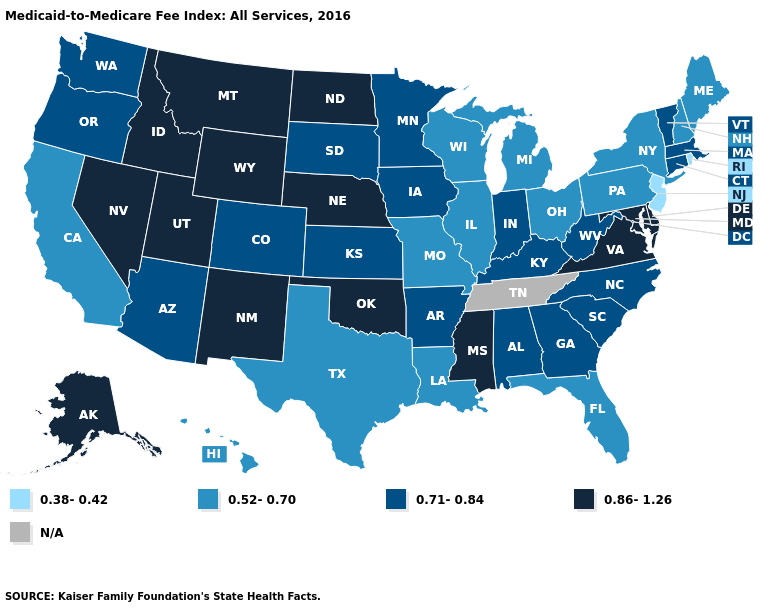What is the value of North Carolina?
Be succinct. 0.71-0.84. What is the highest value in the South ?
Give a very brief answer. 0.86-1.26. What is the lowest value in the USA?
Keep it brief. 0.38-0.42. Name the states that have a value in the range 0.86-1.26?
Be succinct. Alaska, Delaware, Idaho, Maryland, Mississippi, Montana, Nebraska, Nevada, New Mexico, North Dakota, Oklahoma, Utah, Virginia, Wyoming. Among the states that border Nebraska , does Missouri have the lowest value?
Answer briefly. Yes. What is the lowest value in the USA?
Give a very brief answer. 0.38-0.42. Does the map have missing data?
Be succinct. Yes. Does New Jersey have the highest value in the Northeast?
Short answer required. No. Name the states that have a value in the range 0.86-1.26?
Be succinct. Alaska, Delaware, Idaho, Maryland, Mississippi, Montana, Nebraska, Nevada, New Mexico, North Dakota, Oklahoma, Utah, Virginia, Wyoming. Among the states that border Arizona , does California have the highest value?
Concise answer only. No. What is the value of Vermont?
Write a very short answer. 0.71-0.84. What is the value of Virginia?
Give a very brief answer. 0.86-1.26. Does the map have missing data?
Answer briefly. Yes. Which states have the highest value in the USA?
Write a very short answer. Alaska, Delaware, Idaho, Maryland, Mississippi, Montana, Nebraska, Nevada, New Mexico, North Dakota, Oklahoma, Utah, Virginia, Wyoming. Name the states that have a value in the range 0.71-0.84?
Keep it brief. Alabama, Arizona, Arkansas, Colorado, Connecticut, Georgia, Indiana, Iowa, Kansas, Kentucky, Massachusetts, Minnesota, North Carolina, Oregon, South Carolina, South Dakota, Vermont, Washington, West Virginia. 